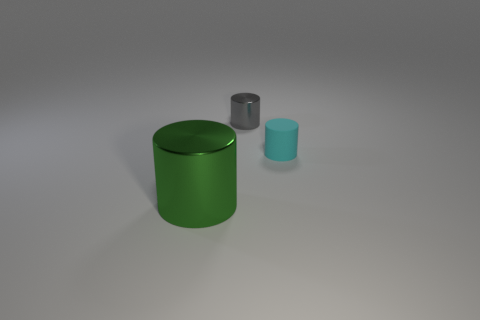What does the color palette in the image suggest about the mood or setting? The muted colors, including the gray background and subdued tones of the cylinders, evoke a minimalistic and modern atmosphere, possibly indicative of a controlled environment like a design studio. 